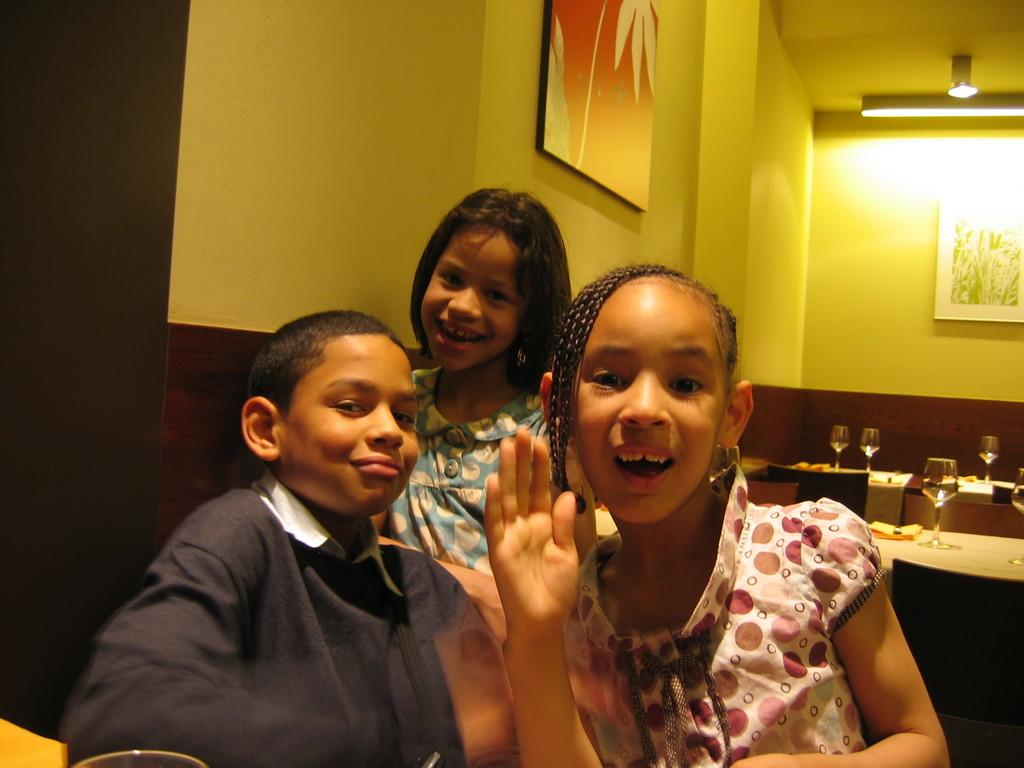What can be seen in the image? There are kids in the image. What objects are present on tables in the image? There are glasses and other objects on tables in the image. What type of furniture is visible in the image? There are chairs in the image. What can be seen on the wall in the background of the image? There are frames on the wall in the background of the image. What type of lighting is present in the background of the image? There are lights in the background of the image. What type of mine is represented in the image? There is no mine present in the image; it features kids, glasses, tables, chairs, frames, and lights. 